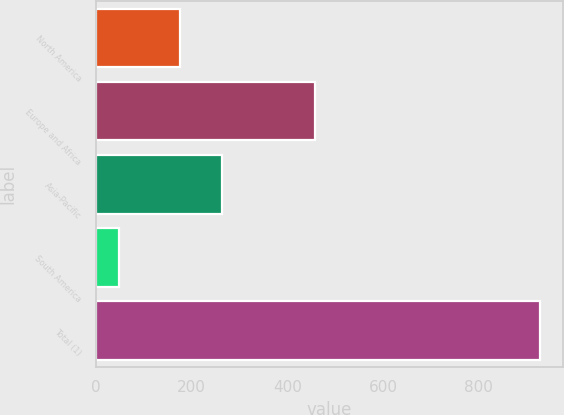Convert chart to OTSL. <chart><loc_0><loc_0><loc_500><loc_500><bar_chart><fcel>North America<fcel>Europe and Africa<fcel>Asia-Pacific<fcel>South America<fcel>Total (1)<nl><fcel>175<fcel>457<fcel>263<fcel>49<fcel>929<nl></chart> 